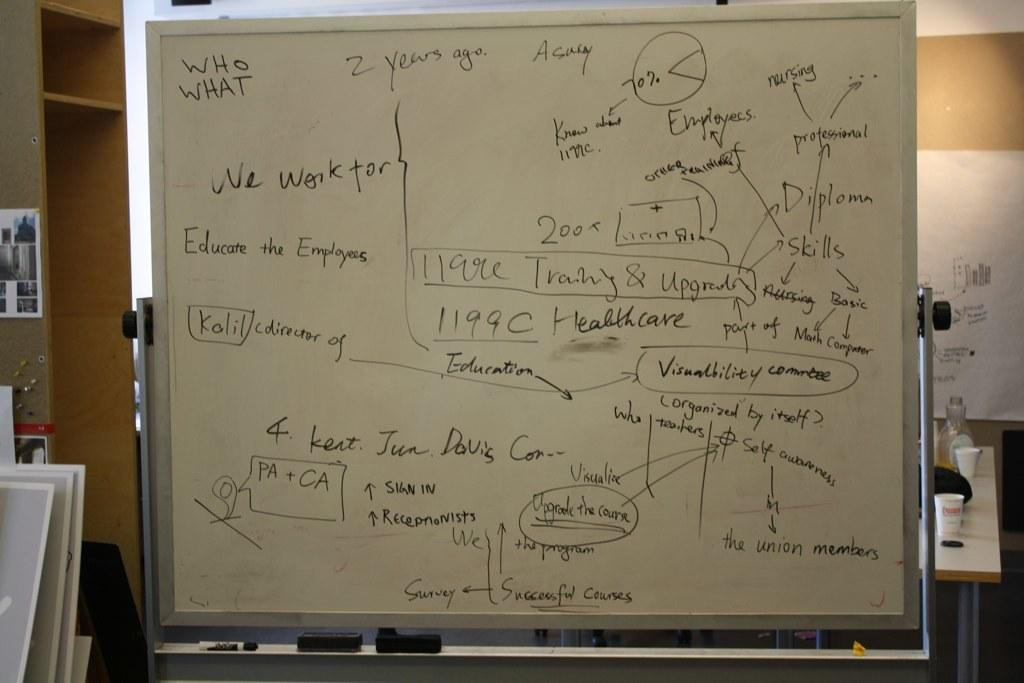Provide a one-sentence caption for the provided image. A white board filled with notes including "Educate the Employees.". 